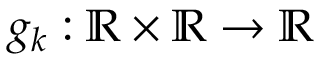<formula> <loc_0><loc_0><loc_500><loc_500>g _ { k } \colon \mathbb { R } \times \mathbb { R } \to \mathbb { R }</formula> 